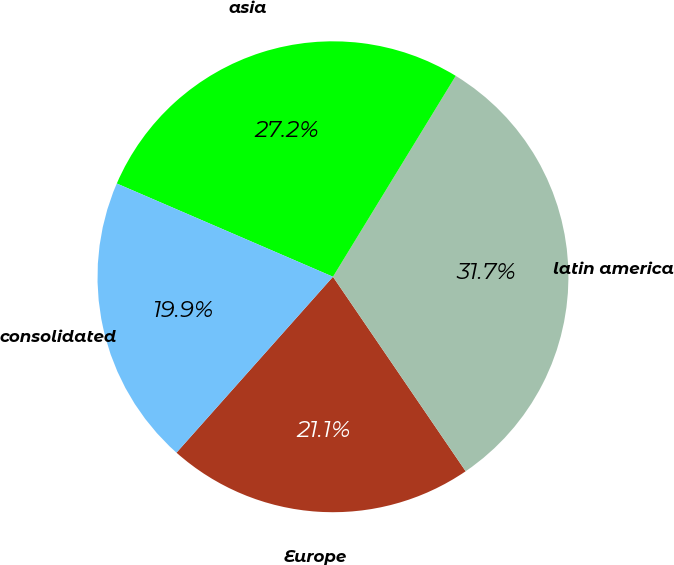Convert chart to OTSL. <chart><loc_0><loc_0><loc_500><loc_500><pie_chart><fcel>Europe<fcel>latin america<fcel>asia<fcel>consolidated<nl><fcel>21.1%<fcel>31.74%<fcel>27.25%<fcel>19.91%<nl></chart> 